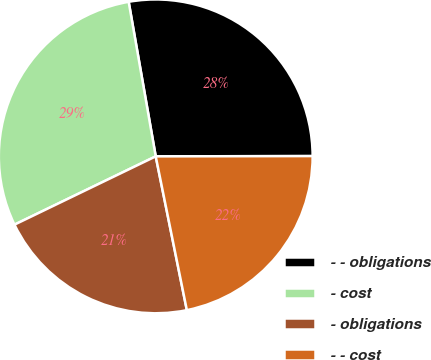Convert chart to OTSL. <chart><loc_0><loc_0><loc_500><loc_500><pie_chart><fcel>- - obligations<fcel>- cost<fcel>- obligations<fcel>- - cost<nl><fcel>27.73%<fcel>29.41%<fcel>21.01%<fcel>21.85%<nl></chart> 